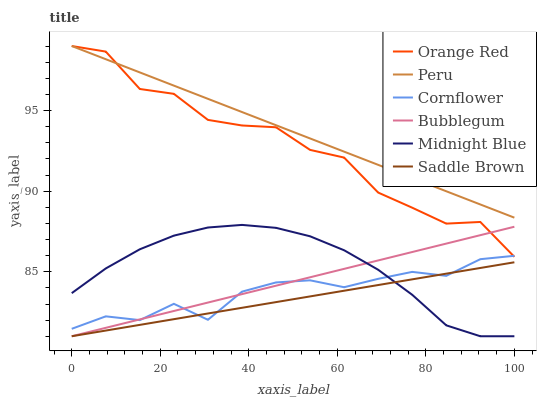Does Saddle Brown have the minimum area under the curve?
Answer yes or no. Yes. Does Peru have the maximum area under the curve?
Answer yes or no. Yes. Does Midnight Blue have the minimum area under the curve?
Answer yes or no. No. Does Midnight Blue have the maximum area under the curve?
Answer yes or no. No. Is Peru the smoothest?
Answer yes or no. Yes. Is Orange Red the roughest?
Answer yes or no. Yes. Is Midnight Blue the smoothest?
Answer yes or no. No. Is Midnight Blue the roughest?
Answer yes or no. No. Does Orange Red have the lowest value?
Answer yes or no. No. Does Peru have the highest value?
Answer yes or no. Yes. Does Midnight Blue have the highest value?
Answer yes or no. No. Is Cornflower less than Peru?
Answer yes or no. Yes. Is Orange Red greater than Saddle Brown?
Answer yes or no. Yes. Does Bubblegum intersect Cornflower?
Answer yes or no. Yes. Is Bubblegum less than Cornflower?
Answer yes or no. No. Is Bubblegum greater than Cornflower?
Answer yes or no. No. Does Cornflower intersect Peru?
Answer yes or no. No. 